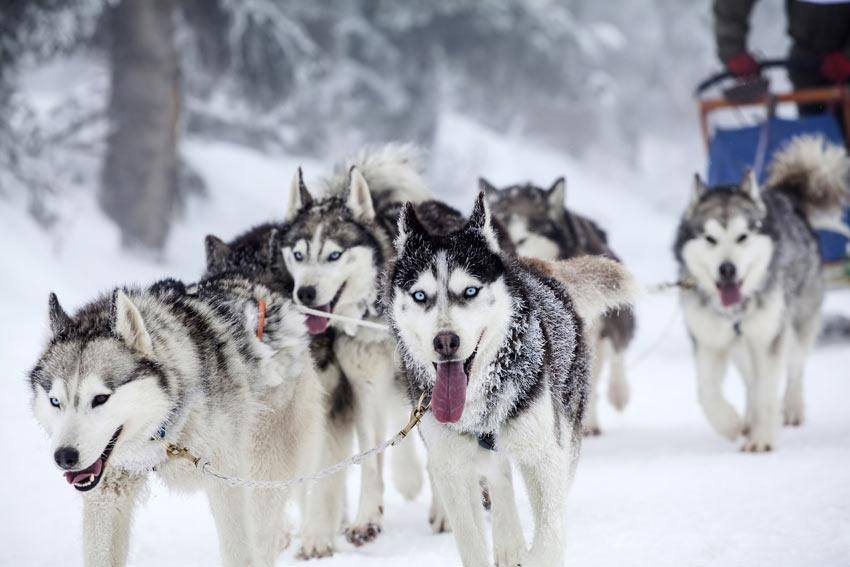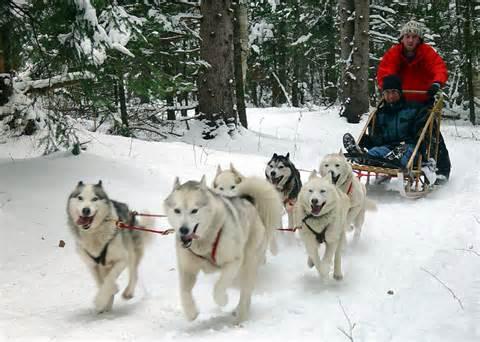The first image is the image on the left, the second image is the image on the right. Given the left and right images, does the statement "The left image contains exactly four sled dogs." hold true? Answer yes or no. No. The first image is the image on the left, the second image is the image on the right. Assess this claim about the two images: "Non-snow-covered evergreens and a flat horizon are behind one of the sled dog teams.". Correct or not? Answer yes or no. No. 